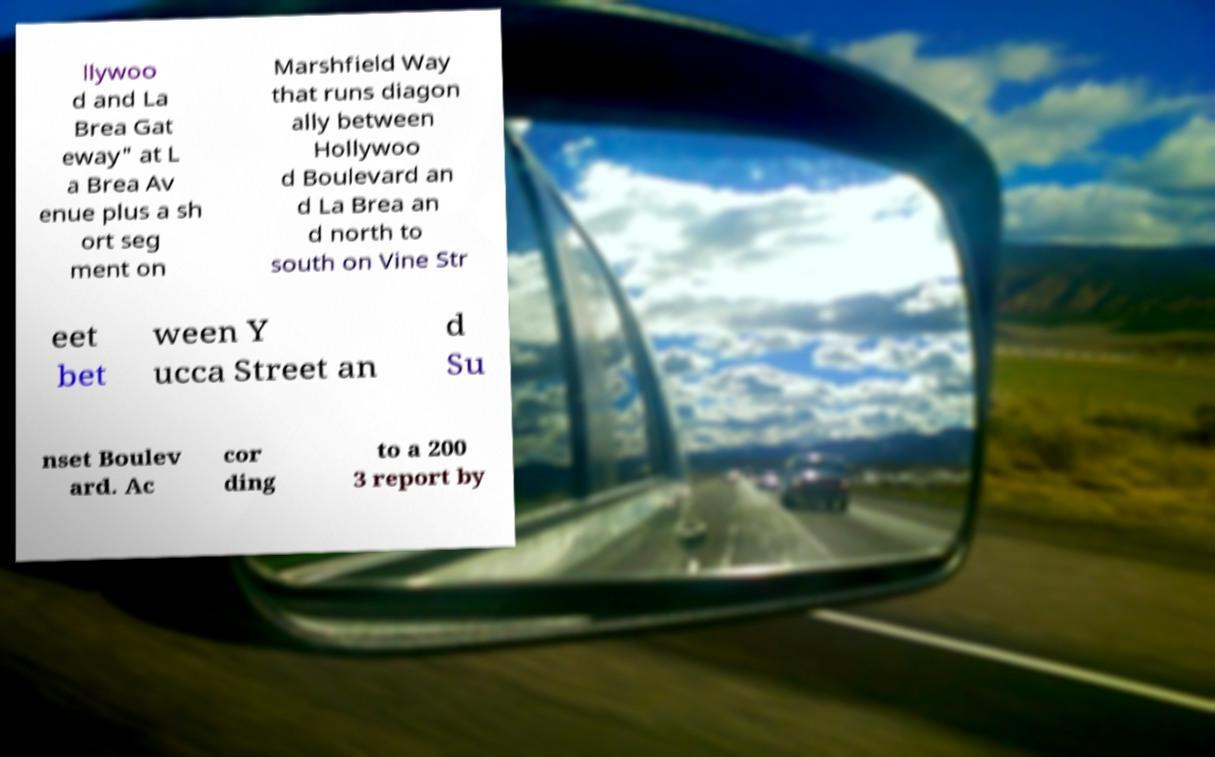Please read and relay the text visible in this image. What does it say? llywoo d and La Brea Gat eway" at L a Brea Av enue plus a sh ort seg ment on Marshfield Way that runs diagon ally between Hollywoo d Boulevard an d La Brea an d north to south on Vine Str eet bet ween Y ucca Street an d Su nset Boulev ard. Ac cor ding to a 200 3 report by 